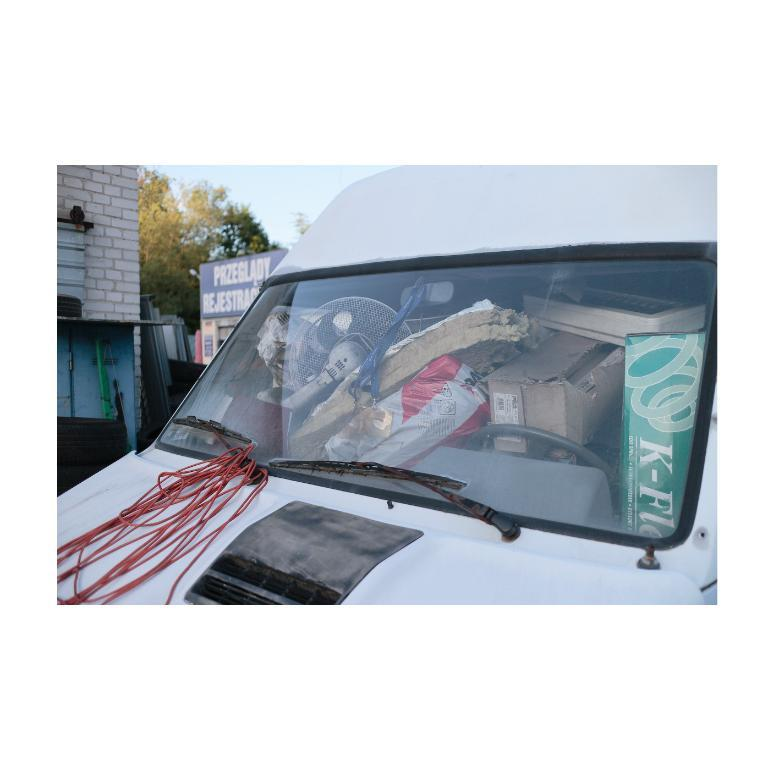What type of vehicle is in the image? There is a vehicle in the image, but the specific type is not mentioned. What can be seen inside the vehicle? A table fan and cardboard boxes are visible inside the vehicle. Are there any other objects inside the vehicle? Yes, there are objects inside the vehicle. What is visible in the background of the image? A wall, a board, trees, and the sky are visible in the background of the image. What type of friction can be observed between the sand and the vehicle's tires in the image? There is no sand present in the image, so it is not possible to observe any friction between sand and the vehicle's tires. 